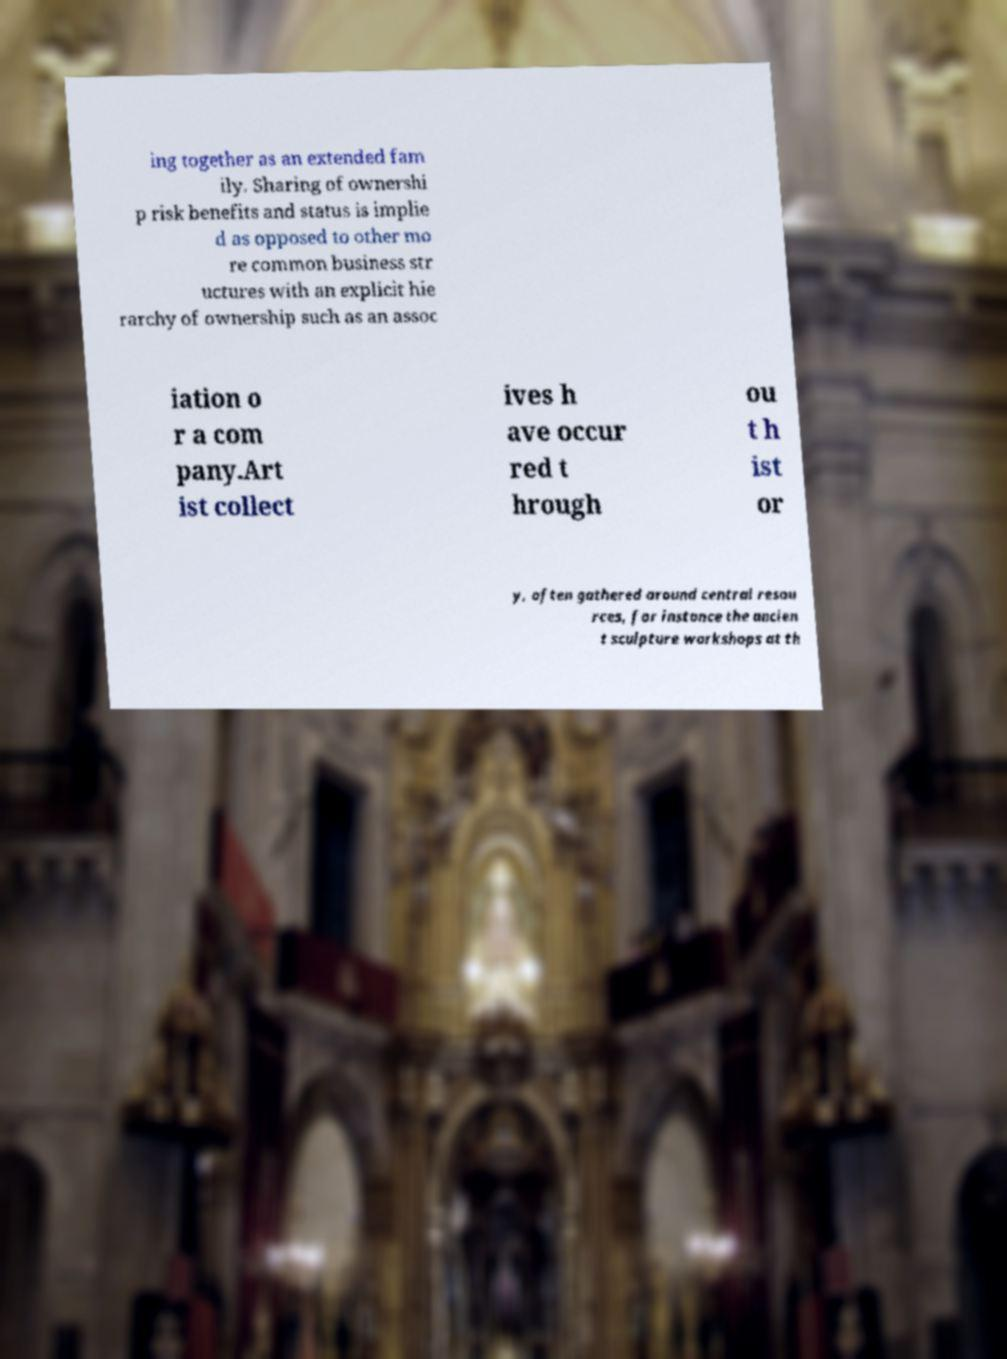Can you read and provide the text displayed in the image?This photo seems to have some interesting text. Can you extract and type it out for me? ing together as an extended fam ily. Sharing of ownershi p risk benefits and status is implie d as opposed to other mo re common business str uctures with an explicit hie rarchy of ownership such as an assoc iation o r a com pany.Art ist collect ives h ave occur red t hrough ou t h ist or y, often gathered around central resou rces, for instance the ancien t sculpture workshops at th 